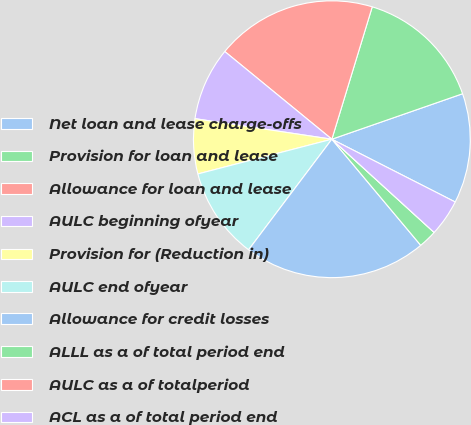Convert chart to OTSL. <chart><loc_0><loc_0><loc_500><loc_500><pie_chart><fcel>Net loan and lease charge-offs<fcel>Provision for loan and lease<fcel>Allowance for loan and lease<fcel>AULC beginning ofyear<fcel>Provision for (Reduction in)<fcel>AULC end ofyear<fcel>Allowance for credit losses<fcel>ALLL as a of total period end<fcel>AULC as a of totalperiod<fcel>ACL as a of total period end<nl><fcel>12.82%<fcel>14.96%<fcel>18.79%<fcel>8.55%<fcel>6.41%<fcel>10.69%<fcel>21.37%<fcel>2.14%<fcel>0.0%<fcel>4.27%<nl></chart> 